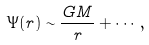<formula> <loc_0><loc_0><loc_500><loc_500>\Psi ( r ) \sim \frac { G M } { r } + \cdots ,</formula> 